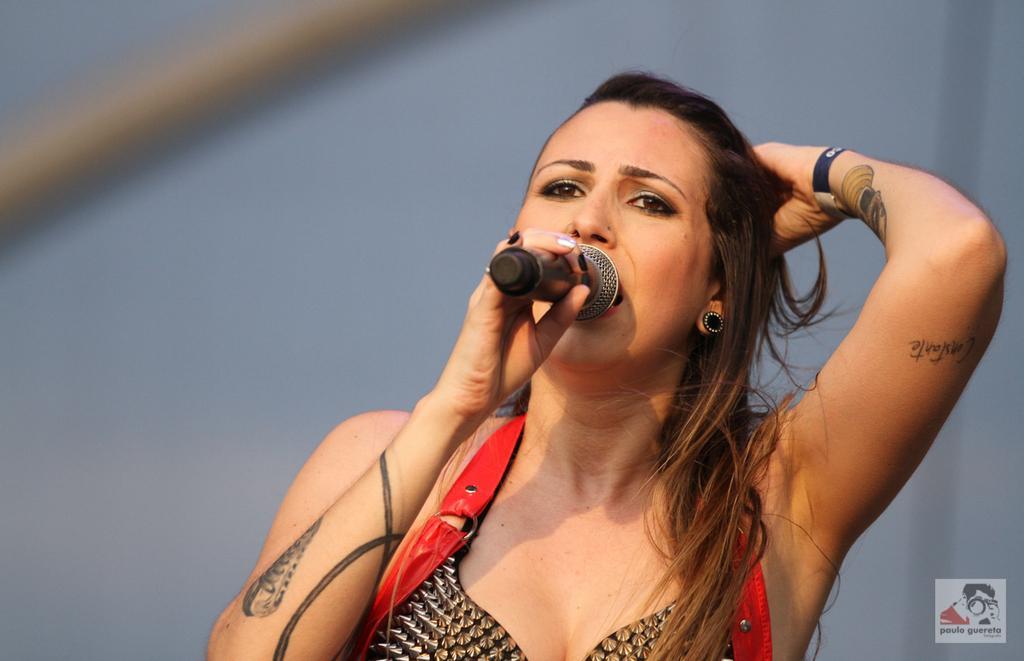How would you summarize this image in a sentence or two? In this picture we can see a woman who is holding a mike with her hand. And she is singing on the mike. 